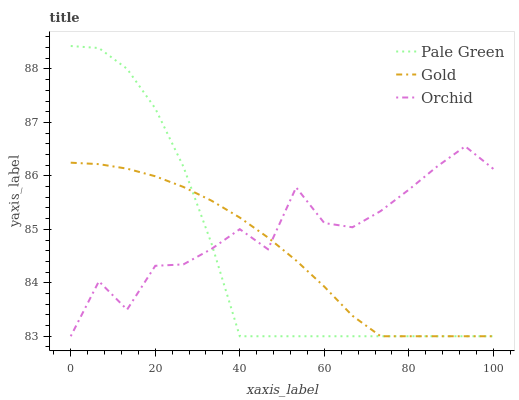Does Pale Green have the minimum area under the curve?
Answer yes or no. Yes. Does Orchid have the maximum area under the curve?
Answer yes or no. Yes. Does Gold have the minimum area under the curve?
Answer yes or no. No. Does Gold have the maximum area under the curve?
Answer yes or no. No. Is Gold the smoothest?
Answer yes or no. Yes. Is Orchid the roughest?
Answer yes or no. Yes. Is Orchid the smoothest?
Answer yes or no. No. Is Gold the roughest?
Answer yes or no. No. Does Pale Green have the highest value?
Answer yes or no. Yes. Does Orchid have the highest value?
Answer yes or no. No. Does Pale Green intersect Orchid?
Answer yes or no. Yes. Is Pale Green less than Orchid?
Answer yes or no. No. Is Pale Green greater than Orchid?
Answer yes or no. No. 